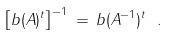<formula> <loc_0><loc_0><loc_500><loc_500>\left [ b ( A ) ^ { t } \right ] ^ { - 1 } \, = \, b ( A ^ { - 1 } ) ^ { t } \ .</formula> 